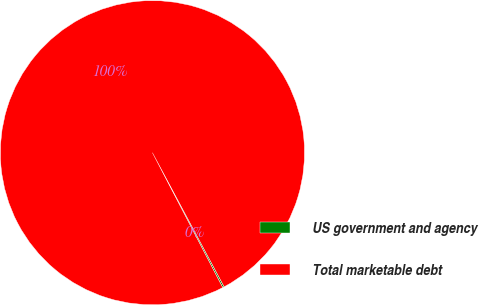<chart> <loc_0><loc_0><loc_500><loc_500><pie_chart><fcel>US government and agency<fcel>Total marketable debt<nl><fcel>0.17%<fcel>99.83%<nl></chart> 